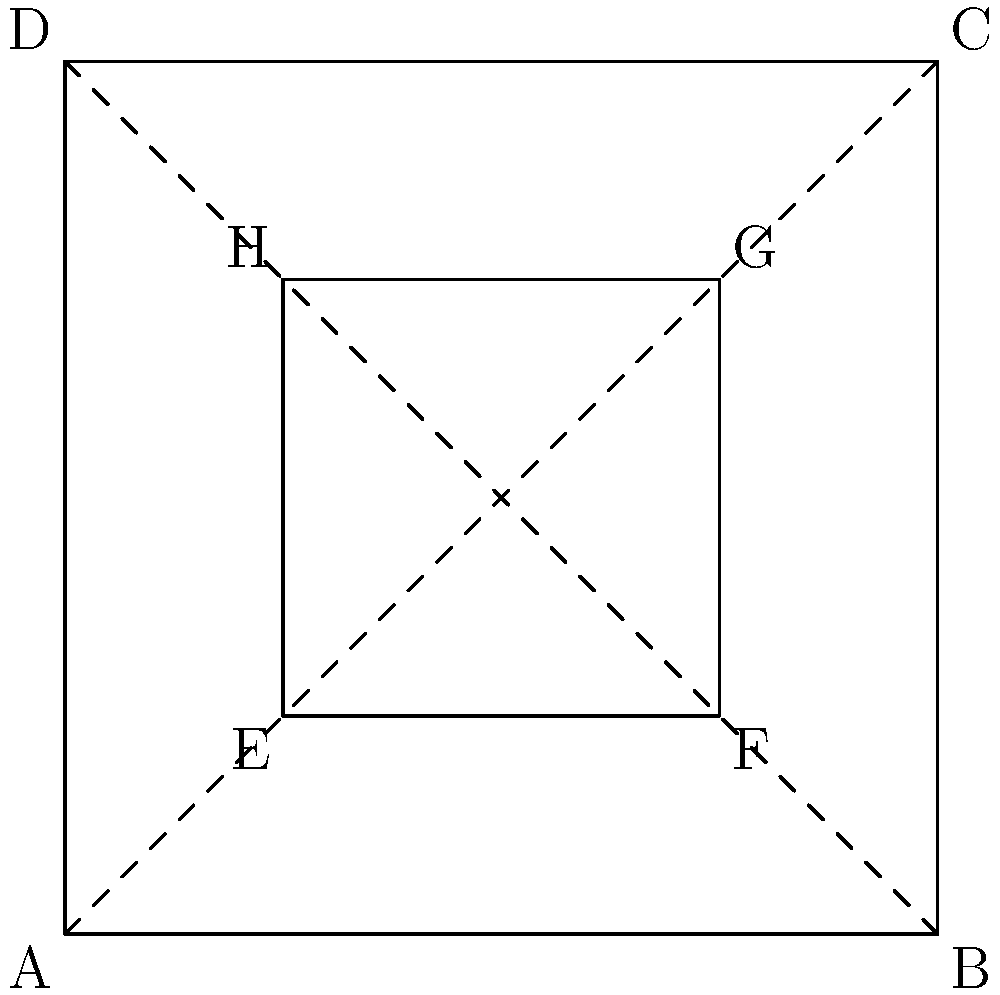In storyboarding for film, one-point perspective is often used to create depth. Consider the diagram above, which represents a basic one-point perspective drawing. If the outer square ABCD represents the frame of the shot, and the inner square EFGH represents an object in the scene, what geometric principle explains why the diagonals AC and BD intersect at the same point as the diagonals of EFGH? To understand this principle, let's break it down step-by-step:

1. In one-point perspective, all parallel lines that are perpendicular to the picture plane converge at a single vanishing point.

2. The diagonals AC and BD of the outer square ABCD intersect at the center of the square. This point is known as the principal point in perspective drawing.

3. The inner square EFGH is a scaled-down version of ABCD, centered at the same point.

4. Due to the properties of similar triangles:
   a. Triangle AEC is similar to triangle EGC
   b. Triangle BFD is similar to triangle FHD

5. Because of this similarity, the diagonals of EFGH (EG and FH) will also pass through the center point where AC and BD intersect.

6. This geometric principle is known as the "preservation of ratios" in perspective drawing.

7. In film terms, this principle ensures that objects at different distances from the camera maintain proper proportional relationships, creating a convincing illusion of depth on a 2D surface.

This geometric principle is crucial in storyboarding as it allows artists to quickly and accurately represent 3D space on a 2D medium, maintaining the visual integrity of the planned shot.
Answer: Preservation of ratios in similar triangles 